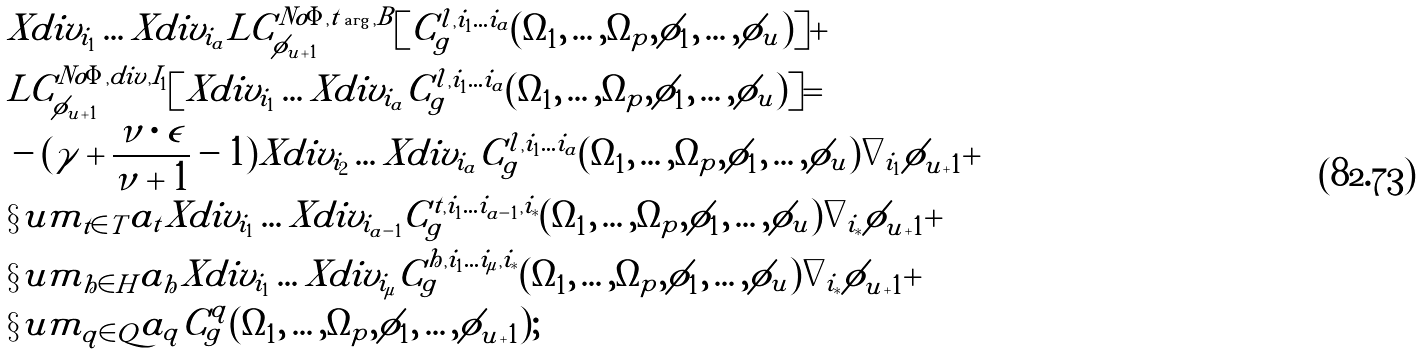<formula> <loc_0><loc_0><loc_500><loc_500>& X d i v _ { i _ { 1 } } \dots X d i v _ { i _ { a } } L C ^ { N o \Phi , t \arg , B } _ { \phi _ { u + 1 } } [ C ^ { l , i _ { 1 } \dots i _ { a } } _ { g } ( \Omega _ { 1 } , \dots , \Omega _ { p } , \phi _ { 1 } , \dots , \phi _ { u } ) ] + \\ & L C ^ { N o \Phi , d i v , I _ { 1 } } _ { \phi _ { u + 1 } } [ X d i v _ { i _ { 1 } } \dots X d i v _ { i _ { a } } C ^ { l , i _ { 1 } \dots i _ { a } } _ { g } ( \Omega _ { 1 } , \dots , \Omega _ { p } , \phi _ { 1 } , \dots , \phi _ { u } ) ] = \\ & - ( \gamma + \frac { \nu \cdot \epsilon } { \nu + 1 } - 1 ) X d i v _ { i _ { 2 } } \dots X d i v _ { i _ { a } } C ^ { l , i _ { 1 } \dots i _ { a } } _ { g } ( \Omega _ { 1 } , \dots , \Omega _ { p } , \phi _ { 1 } , \dots , \phi _ { u } ) \nabla _ { i _ { 1 } } \phi _ { u + 1 } + \\ & \S u m _ { t \in T } a _ { t } X d i v _ { i _ { 1 } } \dots X d i v _ { i _ { a - 1 } } C ^ { t , i _ { 1 } \dots i _ { a - 1 } , i _ { * } } _ { g } ( \Omega _ { 1 } , \dots , \Omega _ { p } , \phi _ { 1 } , \dots , \phi _ { u } ) \nabla _ { i _ { * } } \phi _ { u + 1 } + \\ & \S u m _ { h \in H } a _ { h } X d i v _ { i _ { 1 } } \dots X d i v _ { i _ { \mu } } C ^ { h , i _ { 1 } \dots i _ { \mu } , i _ { * } } _ { g } ( \Omega _ { 1 } , \dots , \Omega _ { p } , \phi _ { 1 } , \dots , \phi _ { u } ) \nabla _ { i _ { * } } \phi _ { u + 1 } + \\ & \S u m _ { q \in Q } a _ { q } C ^ { q } _ { g } ( \Omega _ { 1 } , \dots , \Omega _ { p } , \phi _ { 1 } , \dots , \phi _ { u + 1 } ) ;</formula> 